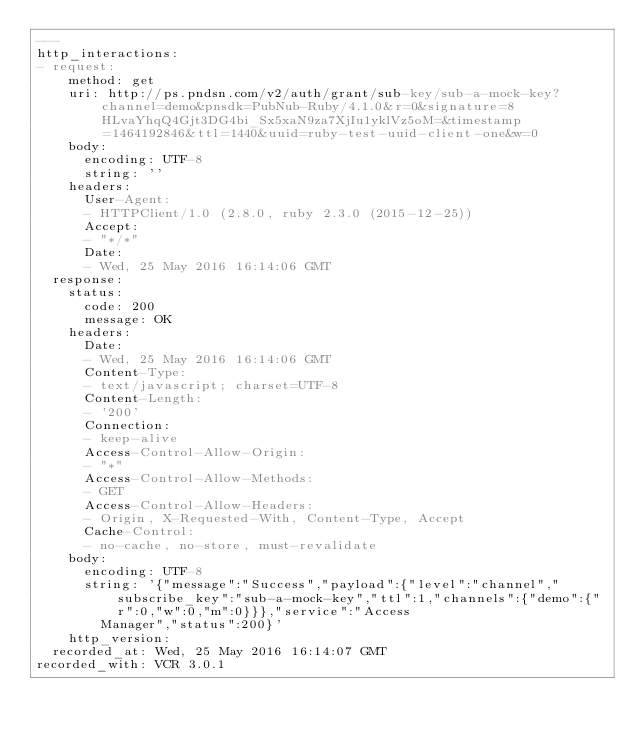<code> <loc_0><loc_0><loc_500><loc_500><_YAML_>---
http_interactions:
- request:
    method: get
    uri: http://ps.pndsn.com/v2/auth/grant/sub-key/sub-a-mock-key?channel=demo&pnsdk=PubNub-Ruby/4.1.0&r=0&signature=8HLvaYhqQ4Gjt3DG4bi_Sx5xaN9za7XjIu1yklVz5oM=&timestamp=1464192846&ttl=1440&uuid=ruby-test-uuid-client-one&w=0
    body:
      encoding: UTF-8
      string: ''
    headers:
      User-Agent:
      - HTTPClient/1.0 (2.8.0, ruby 2.3.0 (2015-12-25))
      Accept:
      - "*/*"
      Date:
      - Wed, 25 May 2016 16:14:06 GMT
  response:
    status:
      code: 200
      message: OK
    headers:
      Date:
      - Wed, 25 May 2016 16:14:06 GMT
      Content-Type:
      - text/javascript; charset=UTF-8
      Content-Length:
      - '200'
      Connection:
      - keep-alive
      Access-Control-Allow-Origin:
      - "*"
      Access-Control-Allow-Methods:
      - GET
      Access-Control-Allow-Headers:
      - Origin, X-Requested-With, Content-Type, Accept
      Cache-Control:
      - no-cache, no-store, must-revalidate
    body:
      encoding: UTF-8
      string: '{"message":"Success","payload":{"level":"channel","subscribe_key":"sub-a-mock-key","ttl":1,"channels":{"demo":{"r":0,"w":0,"m":0}}},"service":"Access
        Manager","status":200}'
    http_version: 
  recorded_at: Wed, 25 May 2016 16:14:07 GMT
recorded_with: VCR 3.0.1
</code> 